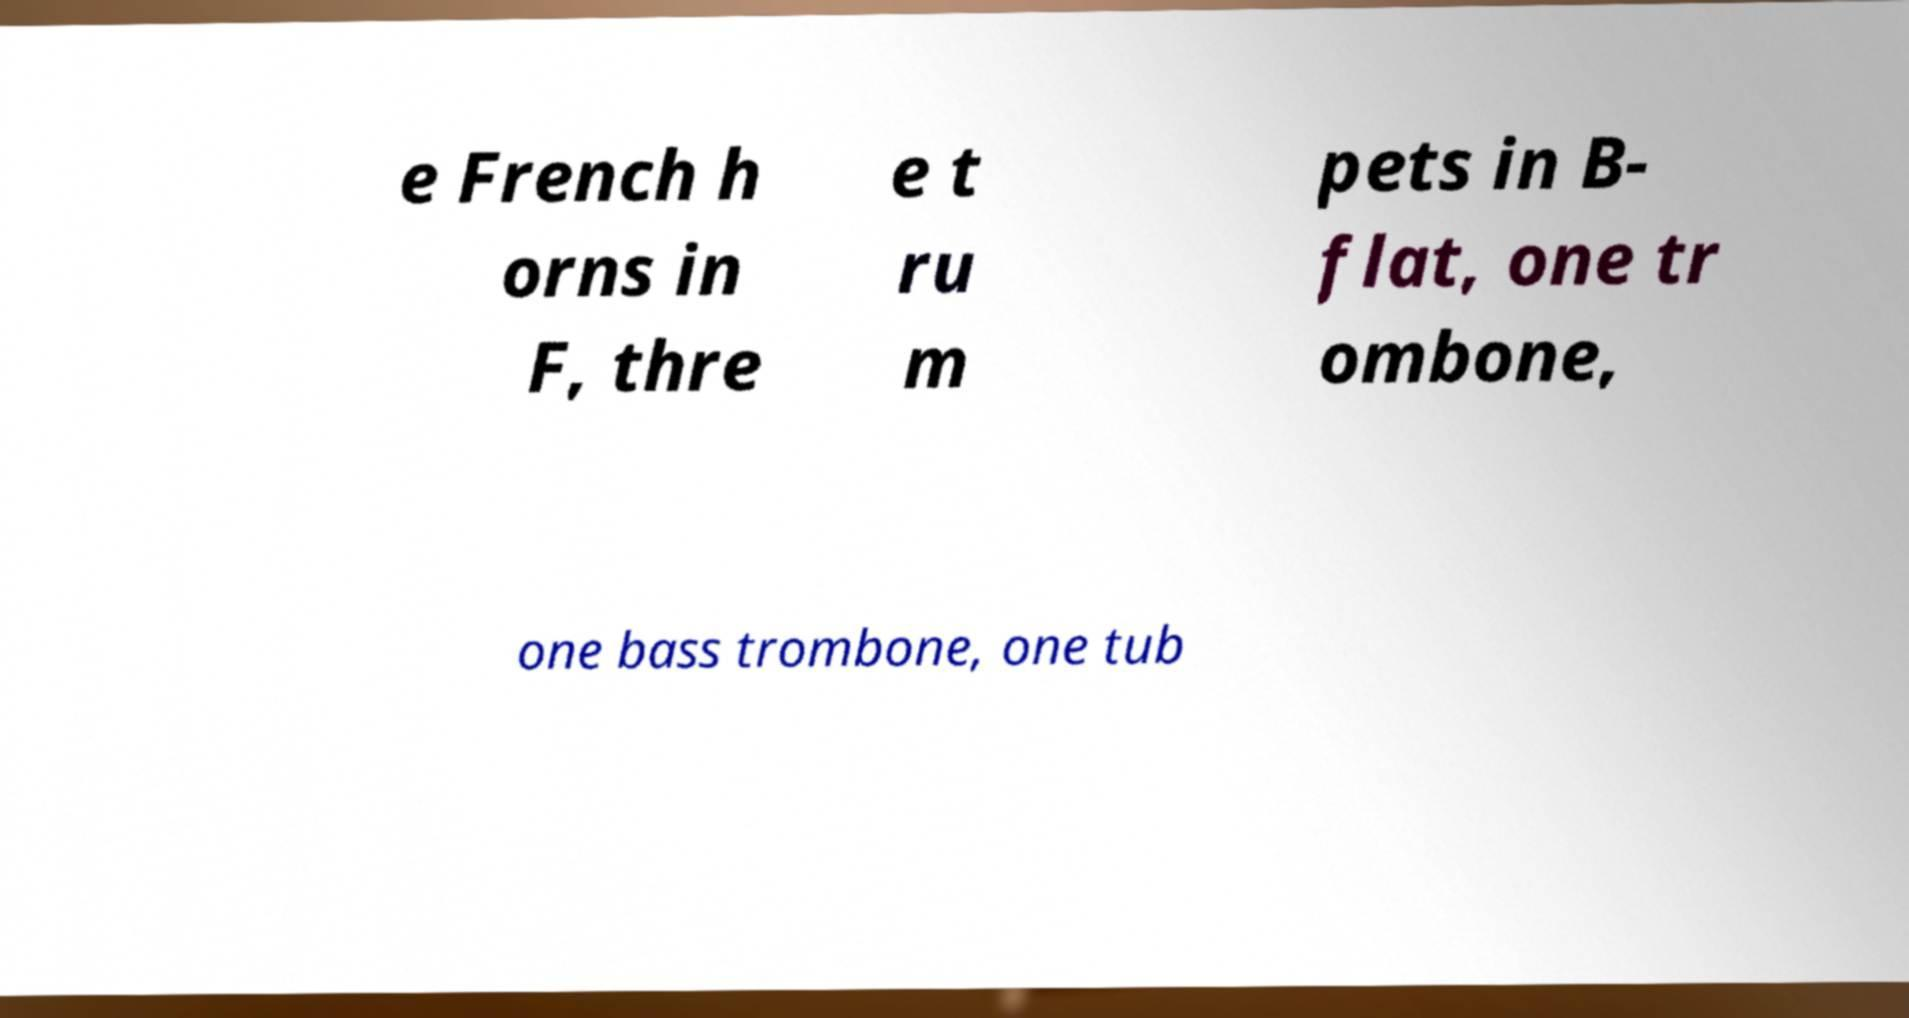I need the written content from this picture converted into text. Can you do that? e French h orns in F, thre e t ru m pets in B- flat, one tr ombone, one bass trombone, one tub 